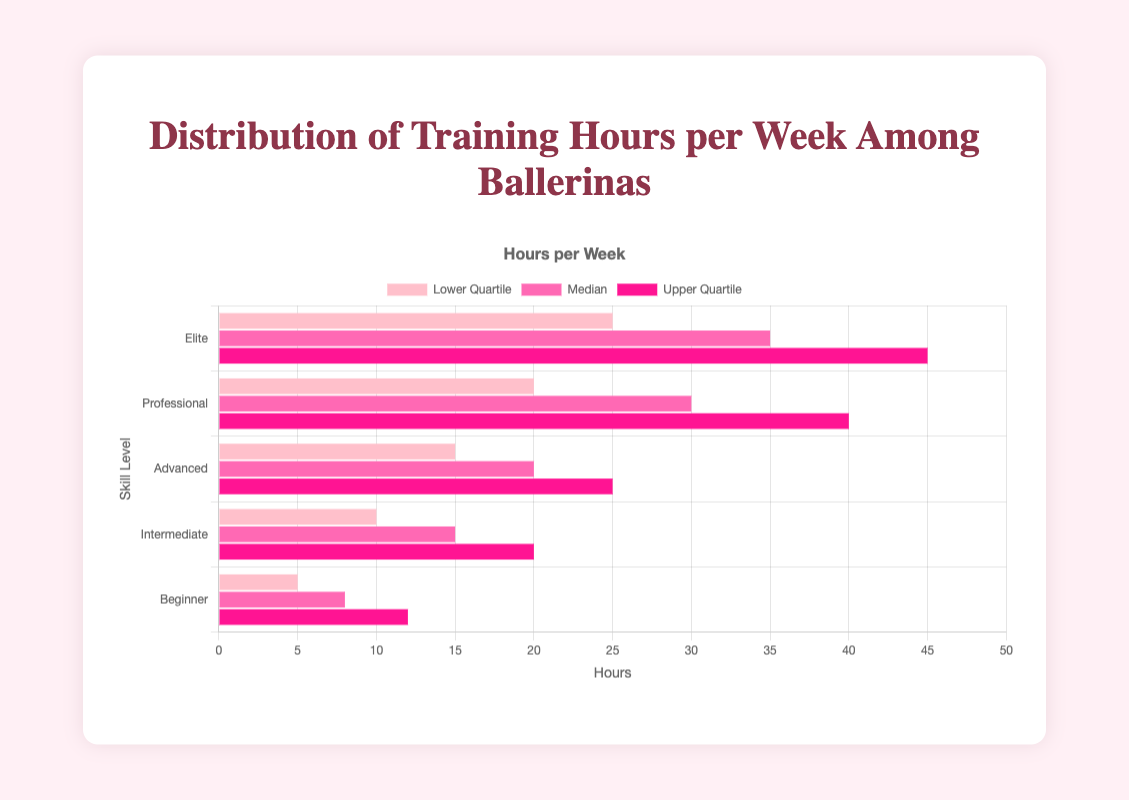Which skill level has the highest median training hours per week? The chart shows that the bars representing the median training hours are tallest for the "Elite" skill level.
Answer: Elite What is the range of training hours (from lowest lower quartile to highest upper quartile) for Intermediate skill level? For Intermediate skill level, the lower quartile is 10 hours, and the upper quartile is 20 hours. Therefore, the range is 20 - 10 = 10 hours.
Answer: 10 hours Which skill level has a median training hours closer to the upper quartile of the Beginner level? The upper quartile for Beginner is 12 hours. The Intermediate skill level has a median training hours of 15 hours, which is closer to 12 than the other levels' medians.
Answer: Intermediate How much greater are the upper quartile training hours of the Professional skill level compared to its lower quartile? For the Professional skill level, the upper quartile is at 40 hours and the lower quartile is at 20 hours, giving a difference of 40 - 20 = 20 hours.
Answer: 20 hours What is the median training hours for the Advanced skill level? The bar representing the median training hours for the Advanced skill level is at 20 hours.
Answer: 20 hours Is the median training hours for the Elite skill level more than double the upper quartile training hours for the Beginner skill level? The median training hours for the Elite skill level is 35 hours. The upper quartile for the Beginner skill level is 12 hours. Two times 12 is 24, and 35 is indeed more than 24.
Answer: Yes By how many hours does the lower quartile of the Elite skill level exceed the upper quartile of the Intermediate skill level? The lower quartile of the Elite skill level is 25 hours, and the upper quartile of the Intermediate skill level is 20 hours. The difference is 25 - 20 = 5 hours.
Answer: 5 hours 